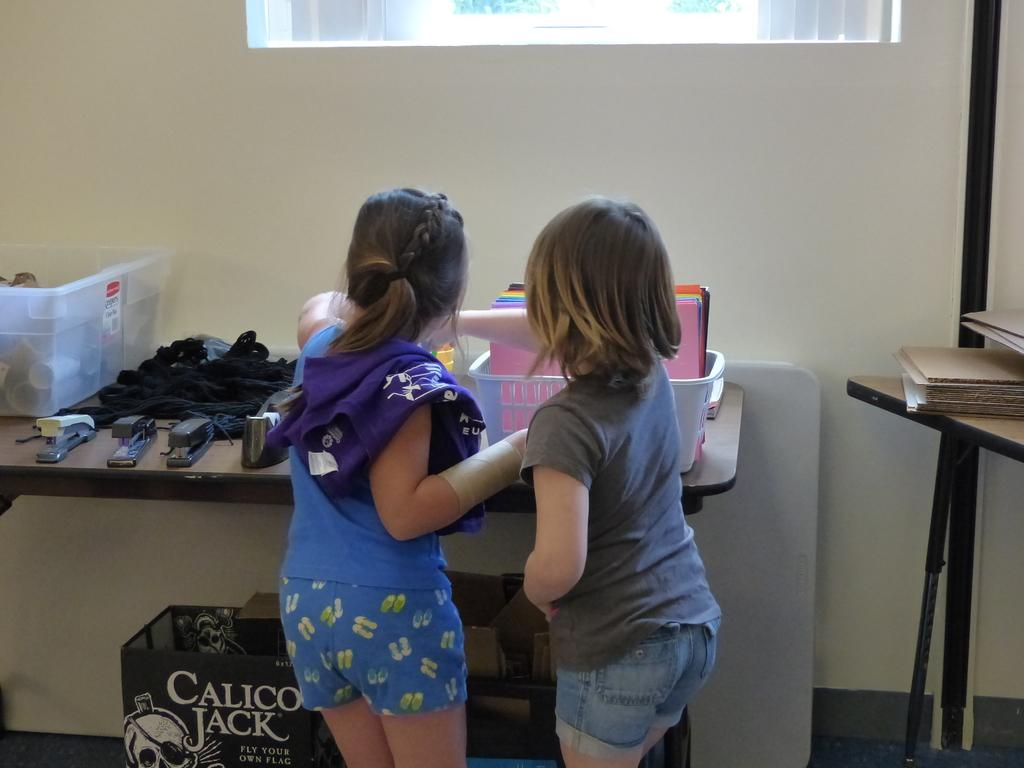<image>
Offer a succinct explanation of the picture presented. Two kids are looking at the things on a table while under it is a calico jack box. 